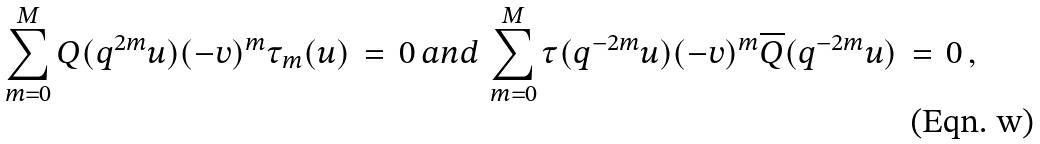Convert formula to latex. <formula><loc_0><loc_0><loc_500><loc_500>\sum _ { m = 0 } ^ { M } Q ( q ^ { 2 m } u ) ( - v ) ^ { m } \tau _ { m } ( u ) \, = \, 0 \, a n d \, \sum _ { m = 0 } ^ { M } \tau ( q ^ { - 2 m } u ) ( - v ) ^ { m } \overline { Q } ( q ^ { - 2 m } u ) \, = \, 0 \, ,</formula> 